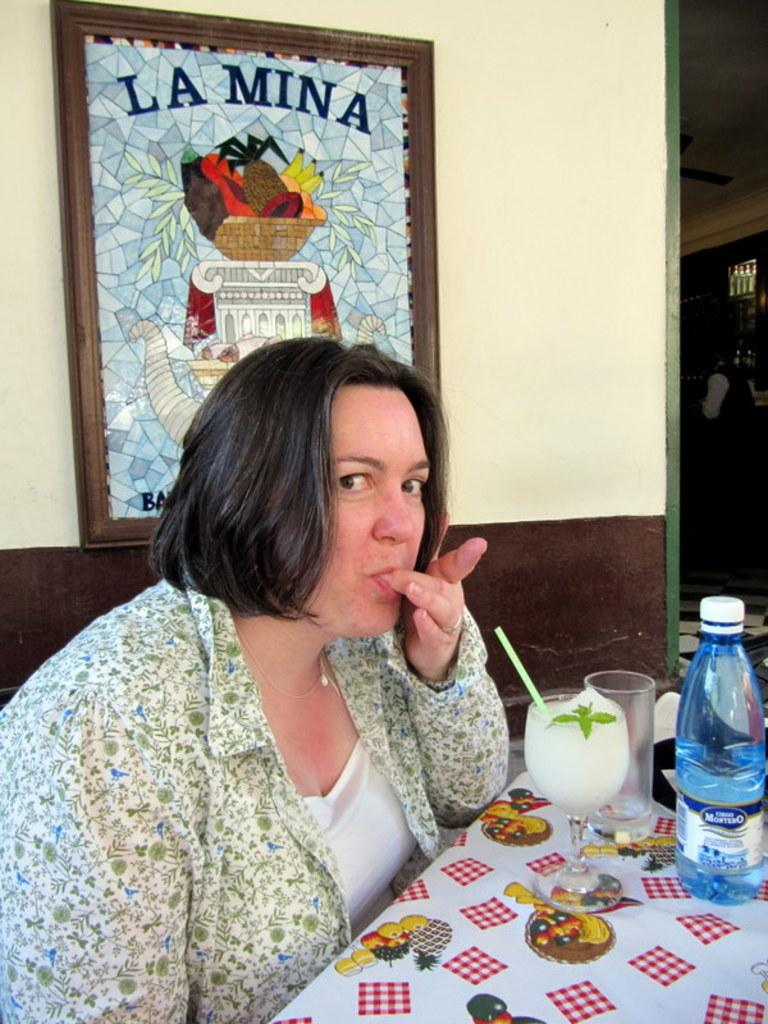What is the lady doing in the image? The lady is sitting near the table in the image. What can be seen on the table? There is a glass with a drink and a bottle on the table. Is there any decoration or item on the wall in the background? Yes, there is a photo frame on the wall in the background. What type of fowl can be seen walking in the front of the image? There is no fowl present in the image; it only features a lady sitting near the table, a glass with a drink, a bottle, and a photo frame on the wall. 